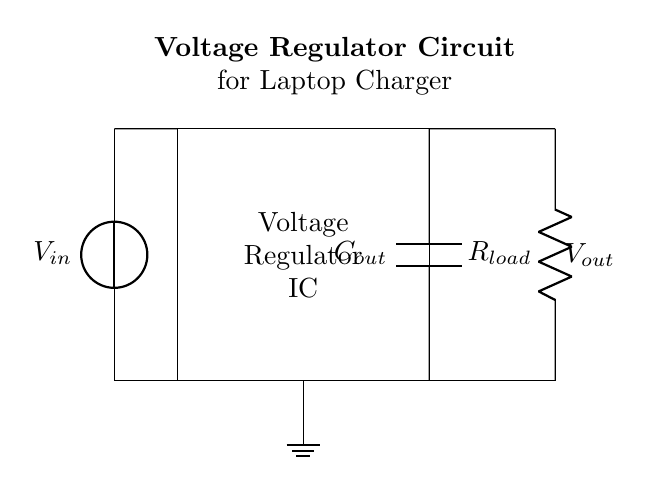What is the function of the voltage regulator IC? The voltage regulator IC is responsible for maintaining a constant output voltage despite variations in input voltage or load conditions. It does this by automatically adjusting its resistance to stabilize the output.
Answer: maintain constant voltage What component is used to smooth the output voltage? The output capacitor (Cout) is used to smooth the output voltage by filtering out fluctuations and providing a stable voltage supply to the load.
Answer: output capacitor What is the load resistance in this circuit? The load resistance (Rload) represents the electrical component or device that consumes the power supplied, and it is marked in the circuit.
Answer: Rload What is the source of the input voltage? The input voltage (Vin) comes from a voltage source, which provides the necessary power for the regulator to operate and supply the load.
Answer: voltage source What type of circuit is this? This is a voltage regulator circuit, specifically designed to regulate and stabilize the output voltage for applications such as laptop chargers, ensuring that the output remains constant under varying input conditions.
Answer: voltage regulator Why is grounding important in this circuit? Grounding is important as it provides a reference point for the voltages in the circuit and helps to ensure safety by preventing floating voltages and potential shock hazards. It also helps stabilize the operation of the voltage regulator.
Answer: safety reference How does the circuit achieve regulation? The circuit achieves regulation by using feedback from the output voltage back to the voltage regulator IC, which adjusts its output to maintain a constant voltage despite changes in input voltage and load.
Answer: feedback mechanism 